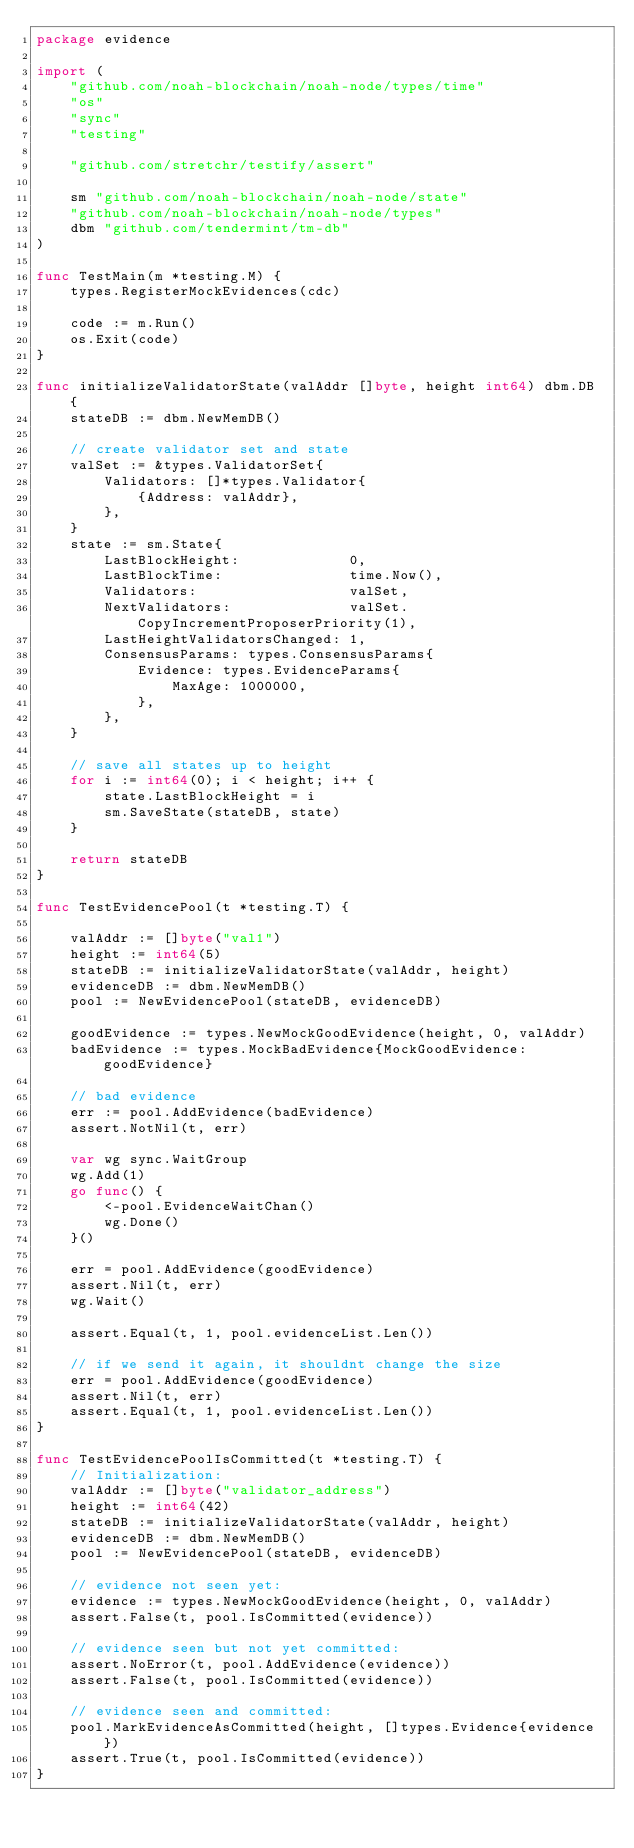Convert code to text. <code><loc_0><loc_0><loc_500><loc_500><_Go_>package evidence

import (
	"github.com/noah-blockchain/noah-node/types/time"
	"os"
	"sync"
	"testing"

	"github.com/stretchr/testify/assert"

	sm "github.com/noah-blockchain/noah-node/state"
	"github.com/noah-blockchain/noah-node/types"
	dbm "github.com/tendermint/tm-db"
)

func TestMain(m *testing.M) {
	types.RegisterMockEvidences(cdc)

	code := m.Run()
	os.Exit(code)
}

func initializeValidatorState(valAddr []byte, height int64) dbm.DB {
	stateDB := dbm.NewMemDB()

	// create validator set and state
	valSet := &types.ValidatorSet{
		Validators: []*types.Validator{
			{Address: valAddr},
		},
	}
	state := sm.State{
		LastBlockHeight:             0,
		LastBlockTime:               time.Now(),
		Validators:                  valSet,
		NextValidators:              valSet.CopyIncrementProposerPriority(1),
		LastHeightValidatorsChanged: 1,
		ConsensusParams: types.ConsensusParams{
			Evidence: types.EvidenceParams{
				MaxAge: 1000000,
			},
		},
	}

	// save all states up to height
	for i := int64(0); i < height; i++ {
		state.LastBlockHeight = i
		sm.SaveState(stateDB, state)
	}

	return stateDB
}

func TestEvidencePool(t *testing.T) {

	valAddr := []byte("val1")
	height := int64(5)
	stateDB := initializeValidatorState(valAddr, height)
	evidenceDB := dbm.NewMemDB()
	pool := NewEvidencePool(stateDB, evidenceDB)

	goodEvidence := types.NewMockGoodEvidence(height, 0, valAddr)
	badEvidence := types.MockBadEvidence{MockGoodEvidence: goodEvidence}

	// bad evidence
	err := pool.AddEvidence(badEvidence)
	assert.NotNil(t, err)

	var wg sync.WaitGroup
	wg.Add(1)
	go func() {
		<-pool.EvidenceWaitChan()
		wg.Done()
	}()

	err = pool.AddEvidence(goodEvidence)
	assert.Nil(t, err)
	wg.Wait()

	assert.Equal(t, 1, pool.evidenceList.Len())

	// if we send it again, it shouldnt change the size
	err = pool.AddEvidence(goodEvidence)
	assert.Nil(t, err)
	assert.Equal(t, 1, pool.evidenceList.Len())
}

func TestEvidencePoolIsCommitted(t *testing.T) {
	// Initialization:
	valAddr := []byte("validator_address")
	height := int64(42)
	stateDB := initializeValidatorState(valAddr, height)
	evidenceDB := dbm.NewMemDB()
	pool := NewEvidencePool(stateDB, evidenceDB)

	// evidence not seen yet:
	evidence := types.NewMockGoodEvidence(height, 0, valAddr)
	assert.False(t, pool.IsCommitted(evidence))

	// evidence seen but not yet committed:
	assert.NoError(t, pool.AddEvidence(evidence))
	assert.False(t, pool.IsCommitted(evidence))

	// evidence seen and committed:
	pool.MarkEvidenceAsCommitted(height, []types.Evidence{evidence})
	assert.True(t, pool.IsCommitted(evidence))
}
</code> 